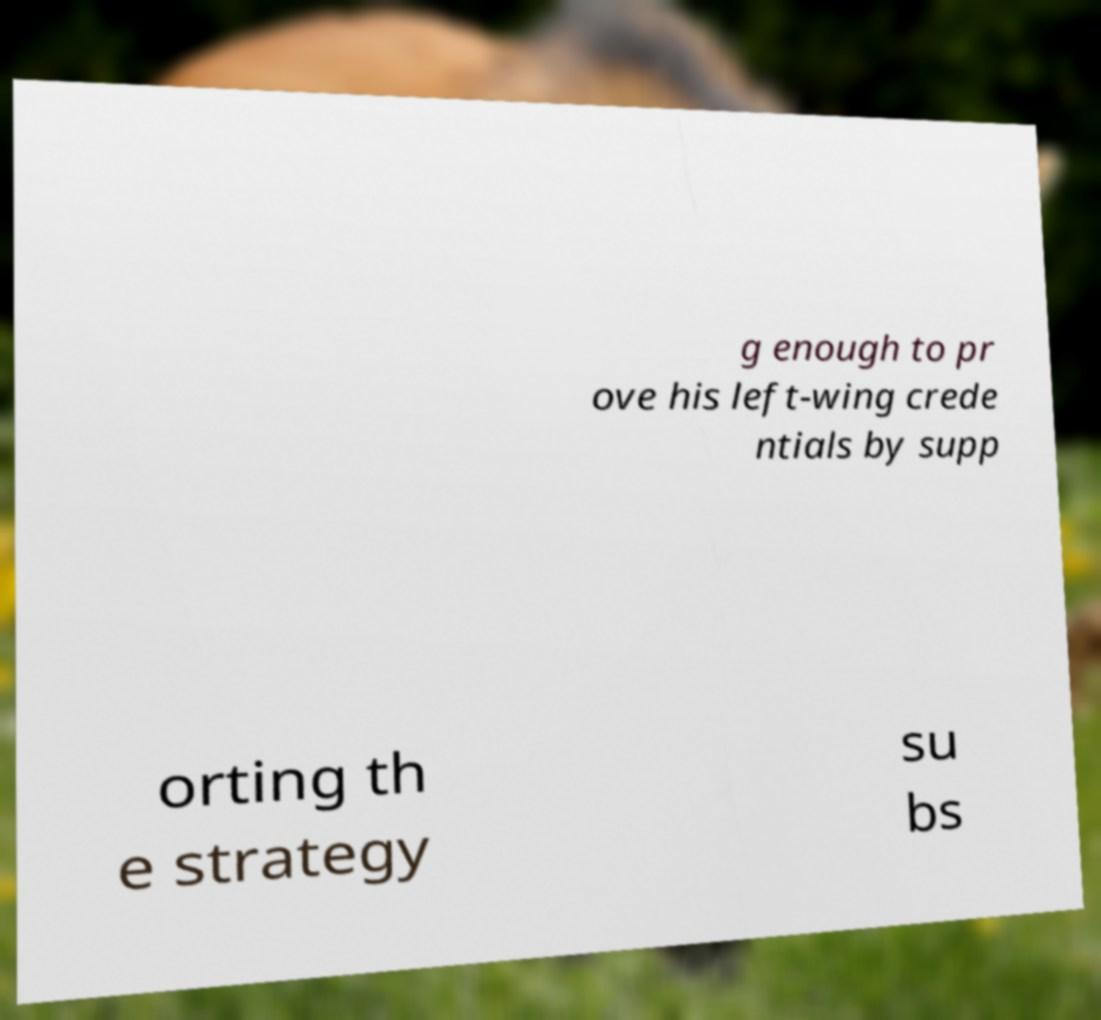Could you assist in decoding the text presented in this image and type it out clearly? g enough to pr ove his left-wing crede ntials by supp orting th e strategy su bs 